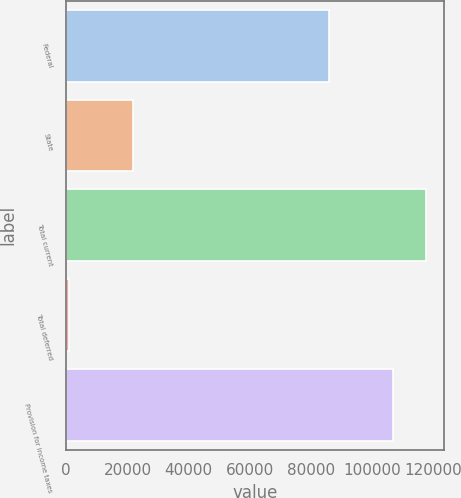Convert chart to OTSL. <chart><loc_0><loc_0><loc_500><loc_500><bar_chart><fcel>Federal<fcel>State<fcel>Total current<fcel>Total deferred<fcel>Provision for income taxes<nl><fcel>86002<fcel>21803<fcel>117527<fcel>962<fcel>106843<nl></chart> 